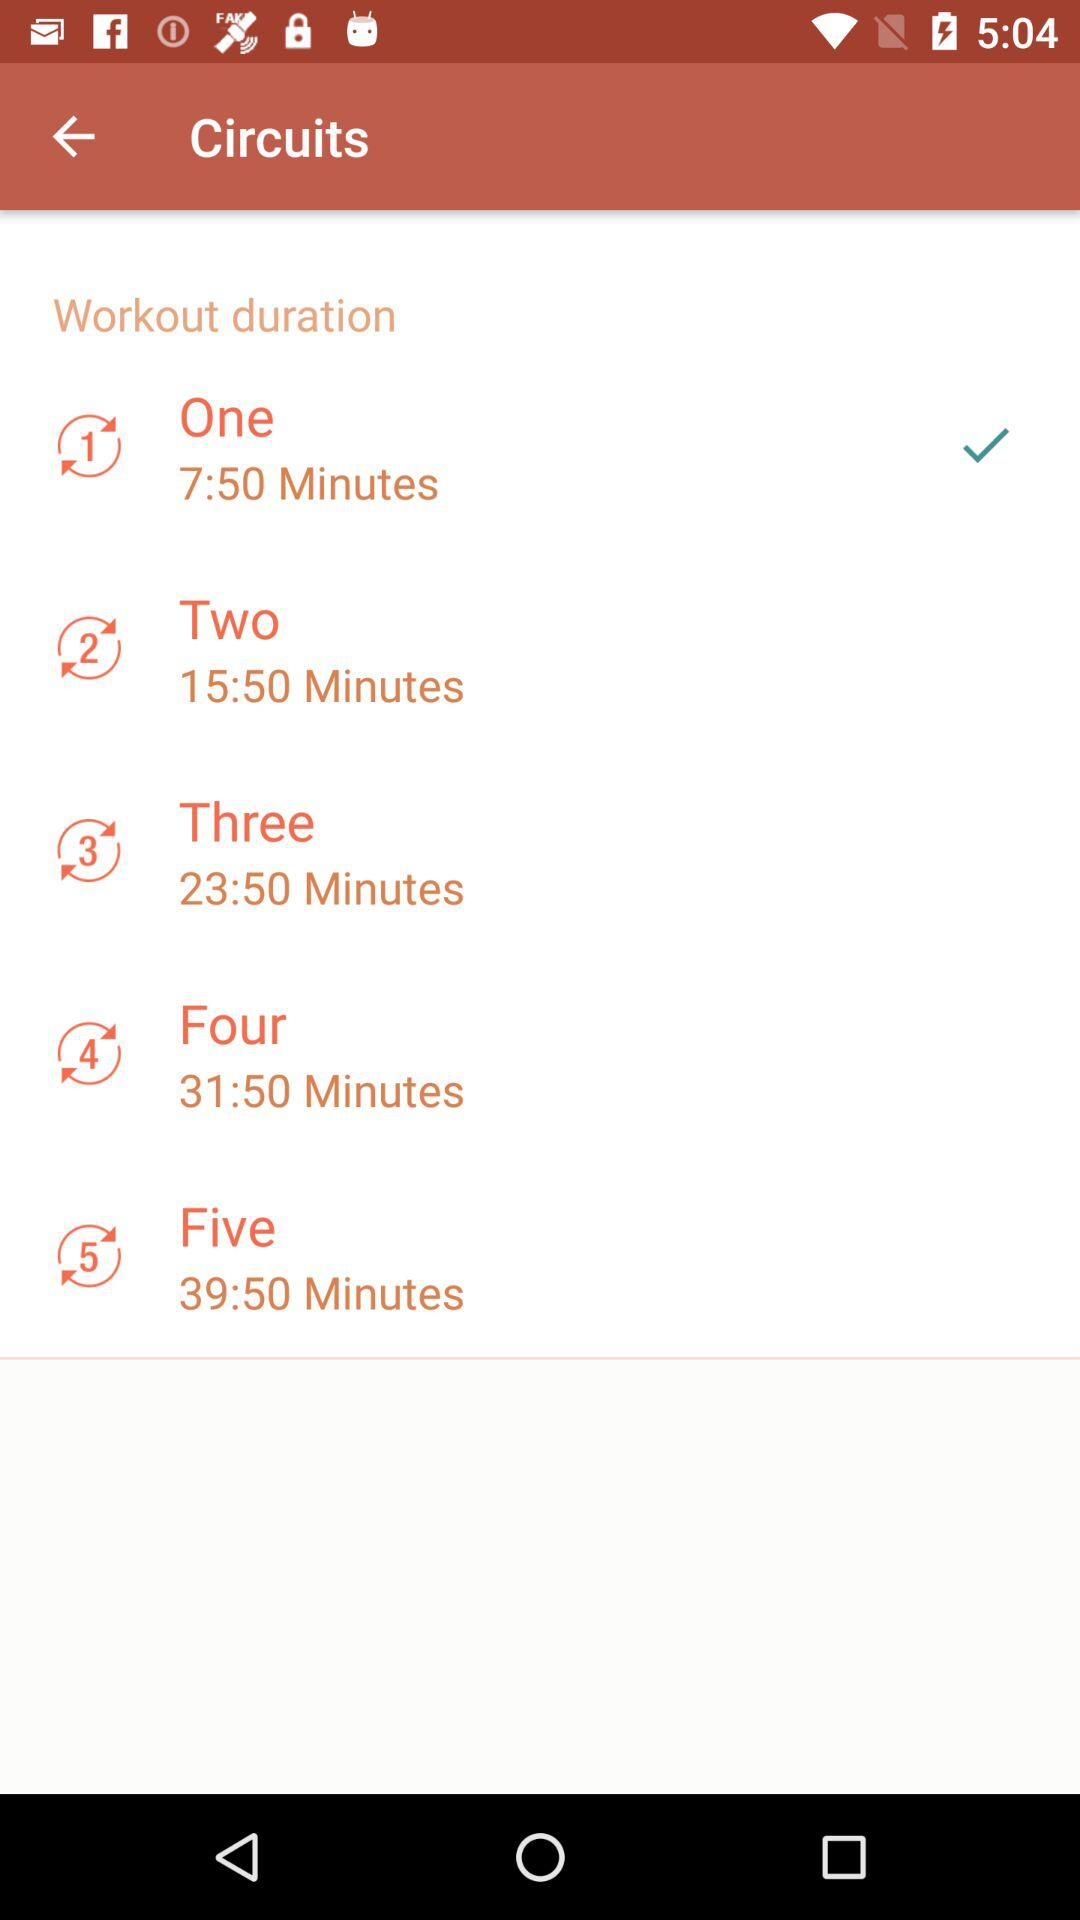What is the workout duration for circuit three? The workout duration for circuit three is 23 minutes 50 seconds. 